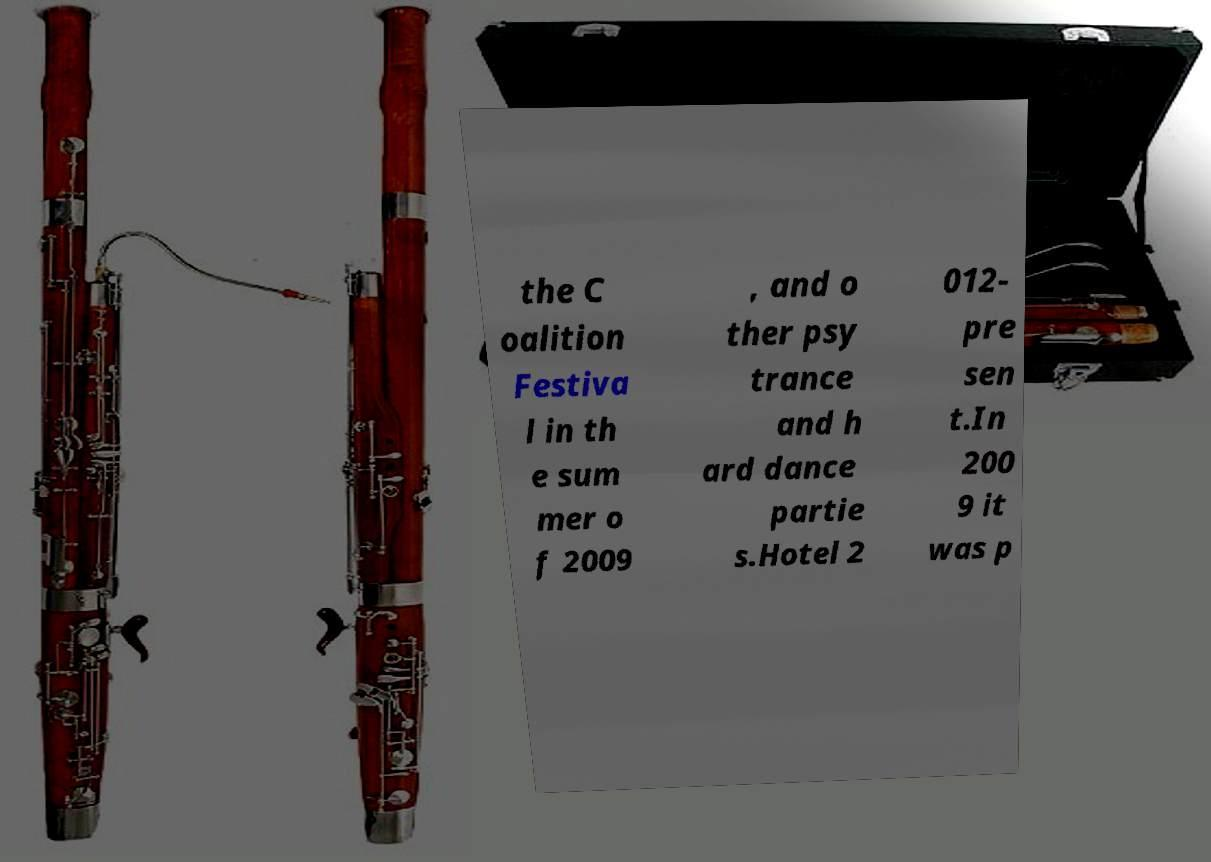Please identify and transcribe the text found in this image. the C oalition Festiva l in th e sum mer o f 2009 , and o ther psy trance and h ard dance partie s.Hotel 2 012- pre sen t.In 200 9 it was p 